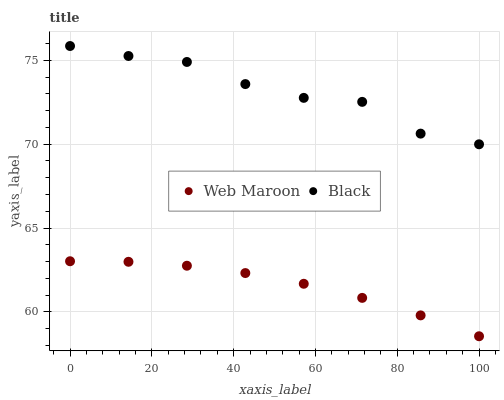Does Web Maroon have the minimum area under the curve?
Answer yes or no. Yes. Does Black have the maximum area under the curve?
Answer yes or no. Yes. Does Web Maroon have the maximum area under the curve?
Answer yes or no. No. Is Web Maroon the smoothest?
Answer yes or no. Yes. Is Black the roughest?
Answer yes or no. Yes. Is Web Maroon the roughest?
Answer yes or no. No. Does Web Maroon have the lowest value?
Answer yes or no. Yes. Does Black have the highest value?
Answer yes or no. Yes. Does Web Maroon have the highest value?
Answer yes or no. No. Is Web Maroon less than Black?
Answer yes or no. Yes. Is Black greater than Web Maroon?
Answer yes or no. Yes. Does Web Maroon intersect Black?
Answer yes or no. No. 